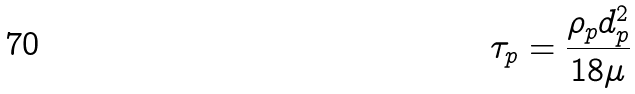<formula> <loc_0><loc_0><loc_500><loc_500>\tau _ { p } = \frac { \rho _ { p } d _ { p } ^ { 2 } } { 1 8 \mu }</formula> 